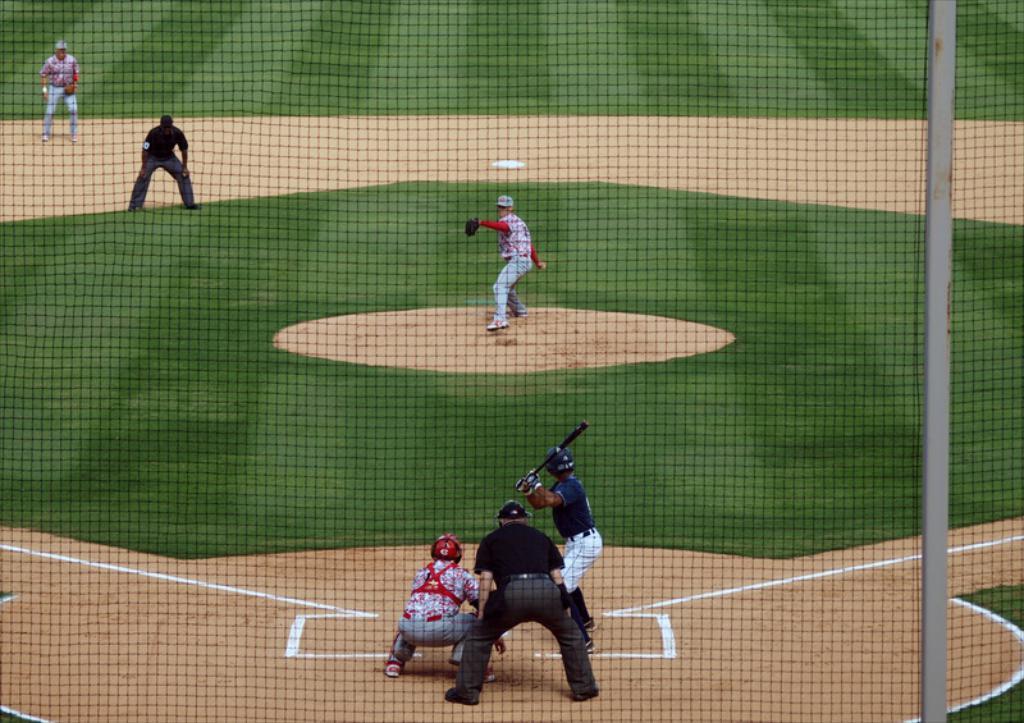Describe this image in one or two sentences. There is a net which is attached to the pole. Outside this net, there are persons playing base ball on the ground on which, there is grass. 